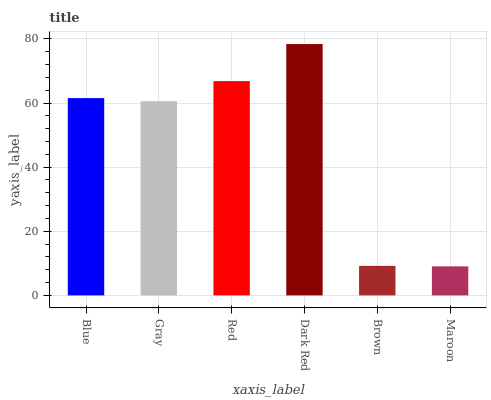Is Maroon the minimum?
Answer yes or no. Yes. Is Dark Red the maximum?
Answer yes or no. Yes. Is Gray the minimum?
Answer yes or no. No. Is Gray the maximum?
Answer yes or no. No. Is Blue greater than Gray?
Answer yes or no. Yes. Is Gray less than Blue?
Answer yes or no. Yes. Is Gray greater than Blue?
Answer yes or no. No. Is Blue less than Gray?
Answer yes or no. No. Is Blue the high median?
Answer yes or no. Yes. Is Gray the low median?
Answer yes or no. Yes. Is Dark Red the high median?
Answer yes or no. No. Is Red the low median?
Answer yes or no. No. 